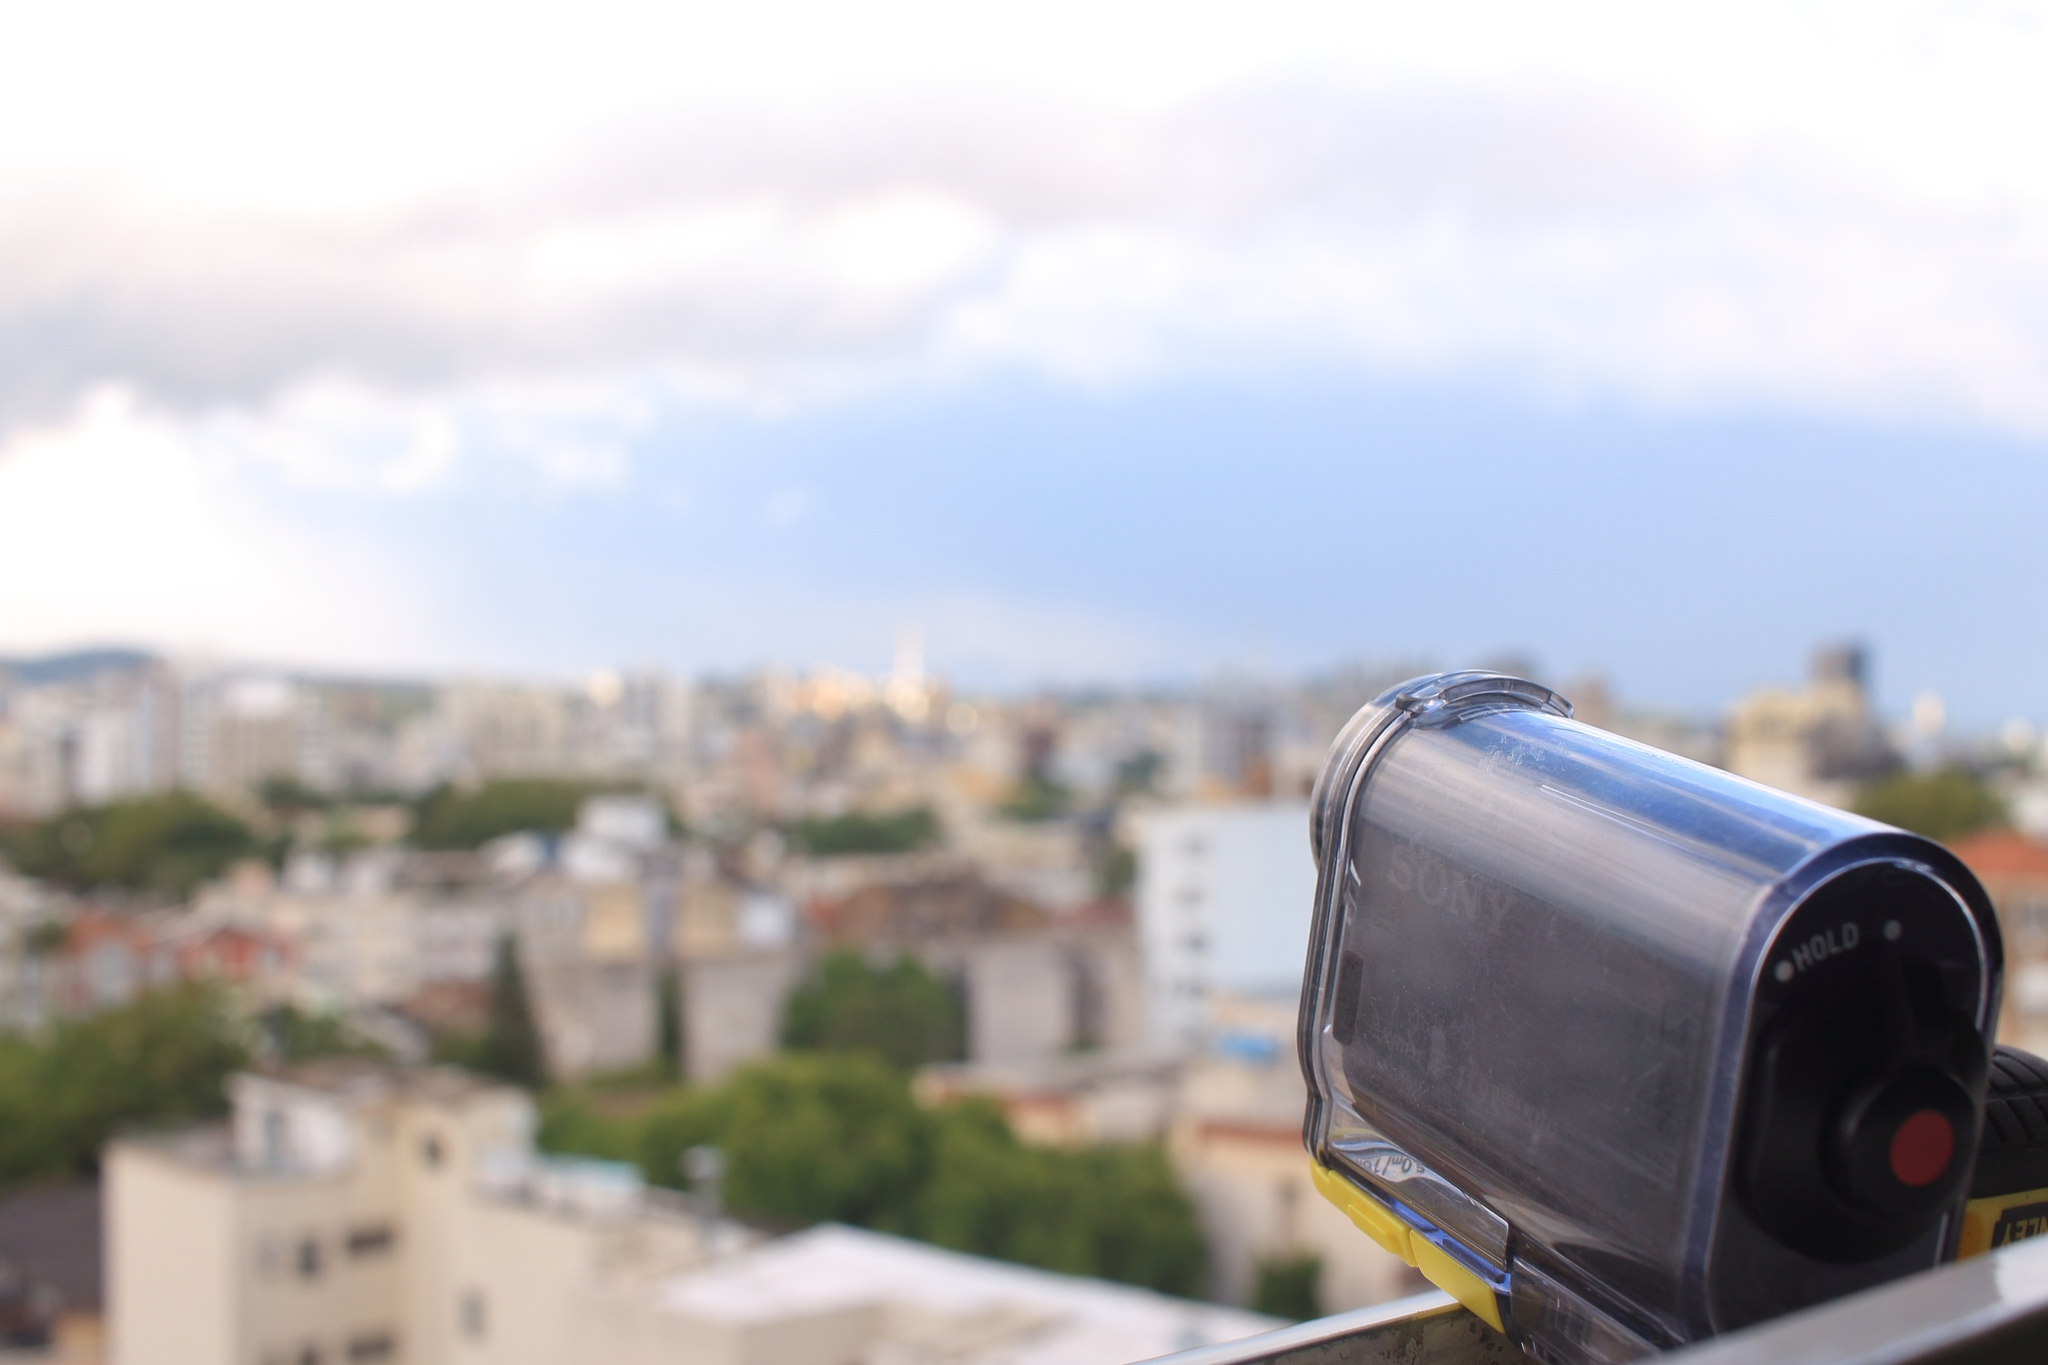Imagine the day in the image from a different perspective. What might be happening in the city? In the city captured by the image, the day is bustling with diverse activities. Office workers are engaged in lively meetings, children are enjoying recess at schools, and cafes are filled with patrons sipping on their morning coffee. In the central park, joggers and dog walkers share the paths, while the city's streets are alive with the hum of traffic and the footsteps of pedestrians. 